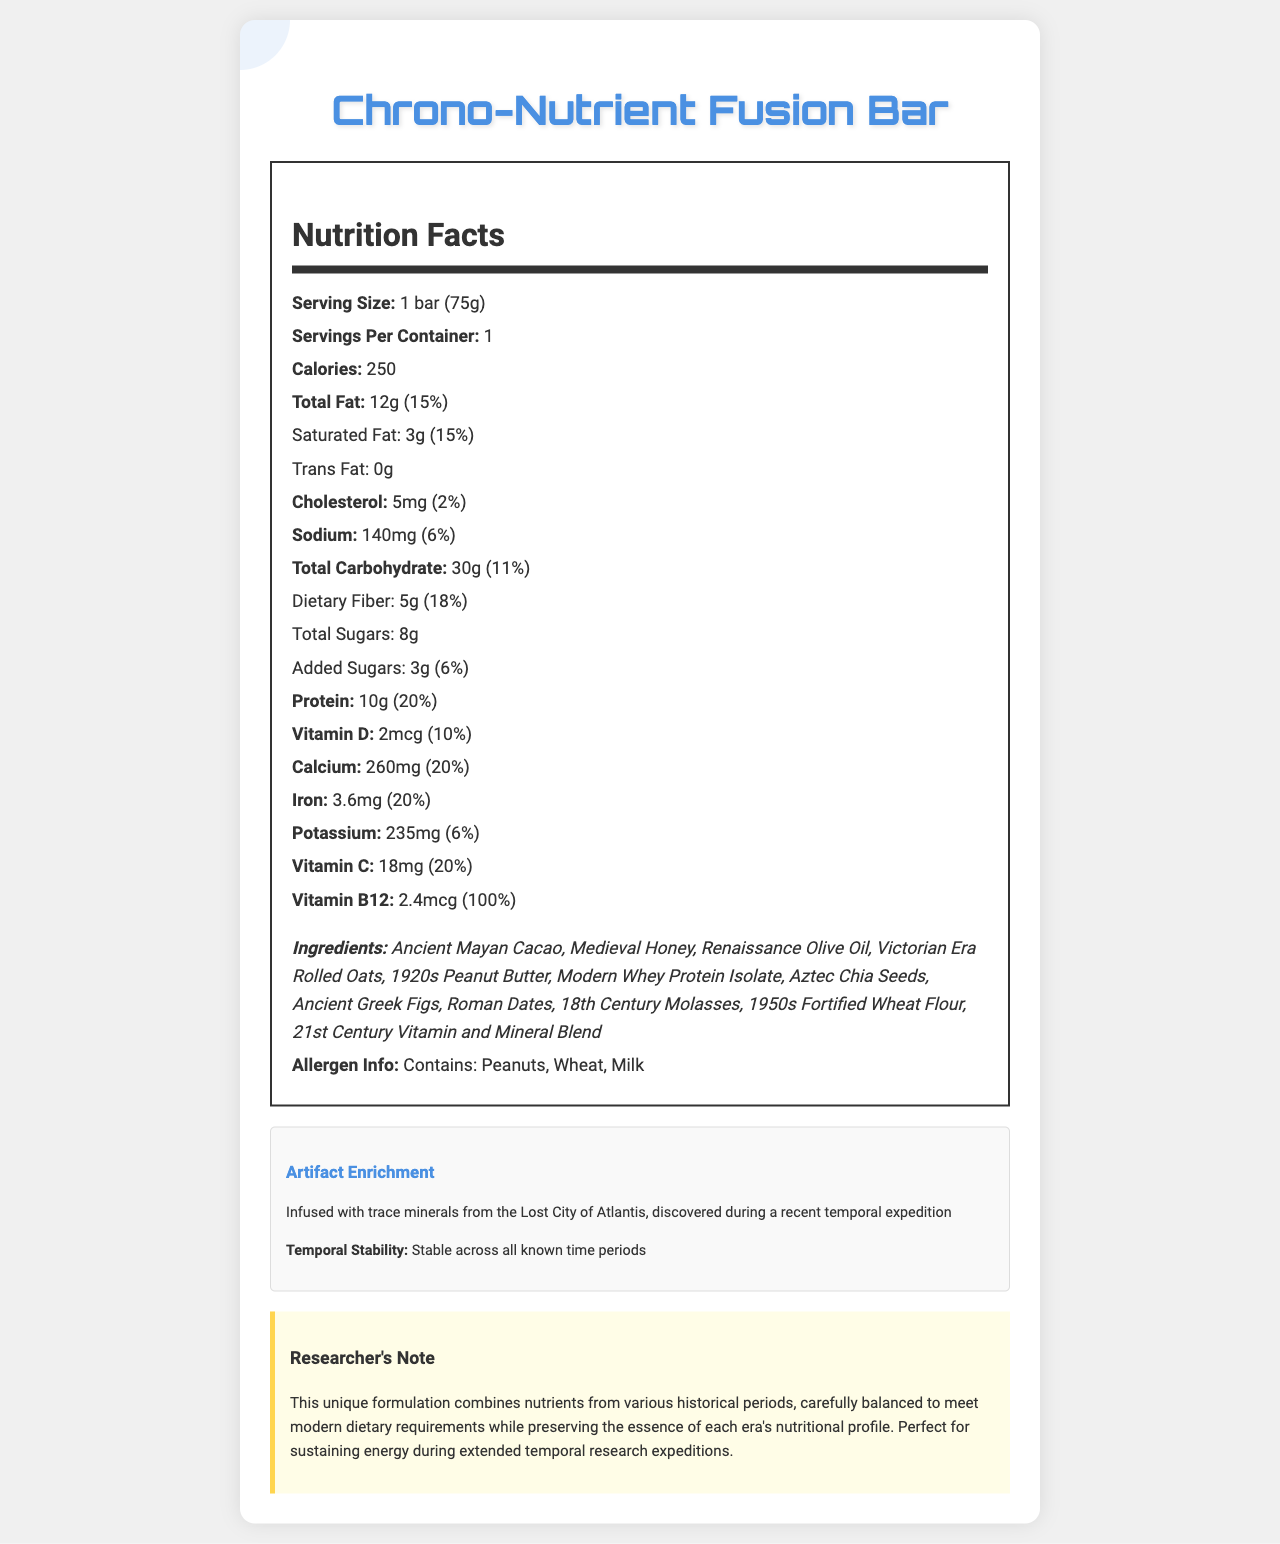what is the serving size of the Chrono-Nutrient Fusion Bar? The document lists the serving size as "1 bar (75g)."
Answer: 1 bar (75g) how many calories are in one serving of the Chrono-Nutrient Fusion Bar? The document states that there are 250 calories per serving.
Answer: 250 what is the amount of sodium per serving? The document specifies that the amount of sodium per serving is 140mg.
Answer: 140mg how much dietary fiber does the Chrono-Nutrient Fusion Bar contain? The document shows that the dietary fiber content per serving is 5g.
Answer: 5g which vitamin has the highest daily value percentage? The document lists Vitamin B12 with a 100% daily value.
Answer: Vitamin B12 how much added sugars are there in each serving? The document mentions that there are 3g of added sugars per serving.
Answer: 3g what ingredients from the document are sourced from ancient civilizations? The document lists ingredients from ancient civilizations: "Ancient Mayan Cacao," "Aztec Chia Seeds," "Ancient Greek Figs," and "Roman Dates."
Answer: Ancient Mayan Cacao, Aztec Chia Seeds, Ancient Greek Figs, Roman Dates how much protein does the Chrono-Nutrient Fusion Bar provide? The document states that the protein content per serving is 10g.
Answer: 10g what allergens are mentioned in the document? The document specifies that the bar contains peanuts, wheat, and milk as allergens.
Answer: Peanuts, Wheat, Milk which of the following is NOT listed as an ingredient in the Chrono-Nutrient Fusion Bar? A. Aztec Chia Seeds B. Victorian Era Rolled Oats C. Modern Almond Butter D. 1920s Peanut Butter The document includes "Aztec Chia Seeds," "Victorian Era Rolled Oats," and "1920s Peanut Butter," but not "Modern Almond Butter."
Answer: C which vitamin has a daily value percentage of 10%? A. Vitamin D B. Calcium C. Iron D. Vitamin C Vitamin D has a daily value percentage of 10%.
Answer: A is the Chrono-Nutrient Fusion Bar stable across all known time periods? The document mentions that the bar is "Stable across all known time periods."
Answer: Yes summarize the main idea of the document. The document provides detailed information on the Chrono-Nutrient Fusion Bar, including its nutritional content, ingredients sourced from different historical eras, and special features like artifact enrichment and temporal stability. It also mentions its suitability for energy sustenance during extended temporal research expeditions.
Answer: The Chrono-Nutrient Fusion Bar is a hypothetical nutritional bar designed for time travelers. It combines ingredients and nutrients from various historical periods to meet modern dietary requirements. The bar is enriched with trace minerals from the Lost City of Atlantis and is designed for stability across all time periods. Various nutritional details, allergen information, and a researcher's note on its unique formulation are provided. what is the historical source of the figs used in the Chrono-Nutrient Fusion Bar? The document lists "Ancient Greek Figs" as one of the ingredients.
Answer: Ancient Greek what percentage of the daily value for calcium does one bar provide? The document indicates that one bar provides 20% of the daily value for calcium.
Answer: 20% what is the daily value percentage of iron provided by the Chrono-Nutrient Fusion Bar? The document mentions that the bar provides 20% of the daily value for iron.
Answer: 20% does the document state the price of the Chrono-Nutrient Fusion Bar? The document does not provide any information regarding the price of the Chrono-Nutrient Fusion Bar.
Answer: Not enough information 